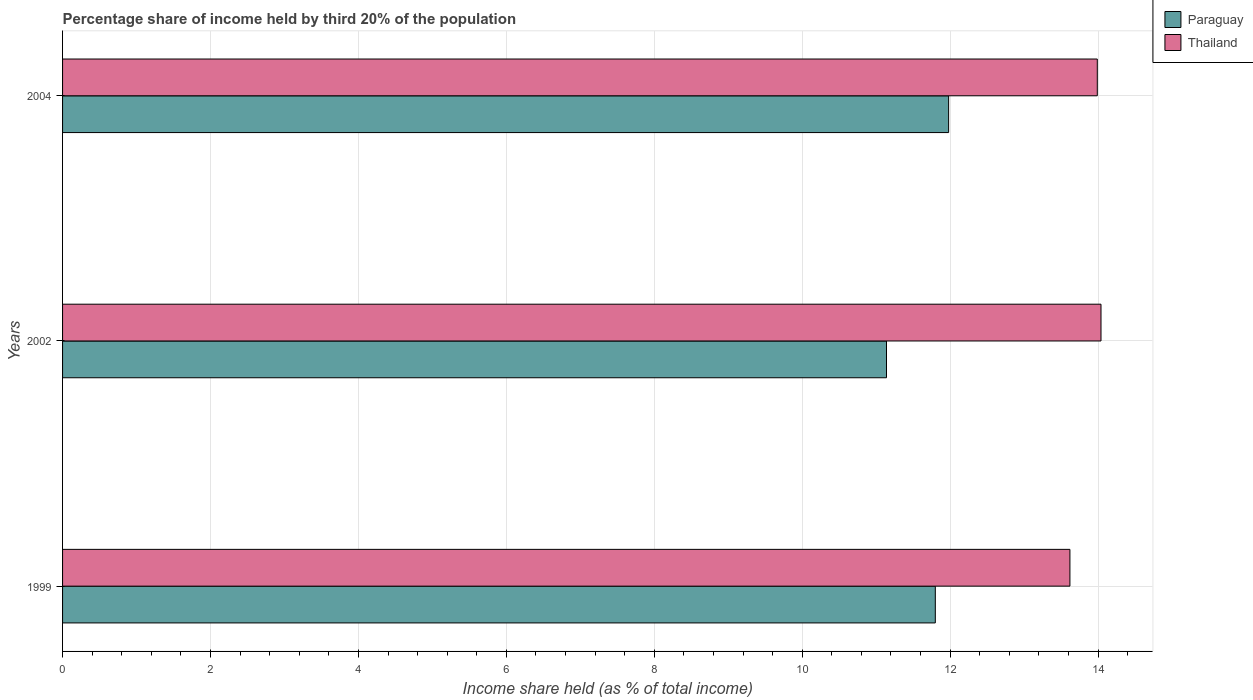How many groups of bars are there?
Keep it short and to the point. 3. Are the number of bars per tick equal to the number of legend labels?
Offer a terse response. Yes. What is the label of the 3rd group of bars from the top?
Keep it short and to the point. 1999. What is the share of income held by third 20% of the population in Thailand in 1999?
Make the answer very short. 13.62. Across all years, what is the maximum share of income held by third 20% of the population in Paraguay?
Your answer should be compact. 11.98. Across all years, what is the minimum share of income held by third 20% of the population in Paraguay?
Make the answer very short. 11.14. In which year was the share of income held by third 20% of the population in Paraguay minimum?
Offer a very short reply. 2002. What is the total share of income held by third 20% of the population in Paraguay in the graph?
Ensure brevity in your answer.  34.92. What is the difference between the share of income held by third 20% of the population in Paraguay in 1999 and that in 2002?
Your answer should be compact. 0.66. What is the difference between the share of income held by third 20% of the population in Paraguay in 2004 and the share of income held by third 20% of the population in Thailand in 1999?
Provide a short and direct response. -1.64. What is the average share of income held by third 20% of the population in Paraguay per year?
Your answer should be compact. 11.64. In the year 2004, what is the difference between the share of income held by third 20% of the population in Thailand and share of income held by third 20% of the population in Paraguay?
Provide a succinct answer. 2.01. What is the ratio of the share of income held by third 20% of the population in Thailand in 1999 to that in 2004?
Give a very brief answer. 0.97. What is the difference between the highest and the second highest share of income held by third 20% of the population in Paraguay?
Make the answer very short. 0.18. What is the difference between the highest and the lowest share of income held by third 20% of the population in Thailand?
Your answer should be compact. 0.42. In how many years, is the share of income held by third 20% of the population in Paraguay greater than the average share of income held by third 20% of the population in Paraguay taken over all years?
Offer a very short reply. 2. Is the sum of the share of income held by third 20% of the population in Thailand in 1999 and 2004 greater than the maximum share of income held by third 20% of the population in Paraguay across all years?
Your answer should be very brief. Yes. What does the 1st bar from the top in 2004 represents?
Your answer should be compact. Thailand. What does the 1st bar from the bottom in 2004 represents?
Provide a short and direct response. Paraguay. Are all the bars in the graph horizontal?
Offer a very short reply. Yes. How many years are there in the graph?
Ensure brevity in your answer.  3. What is the difference between two consecutive major ticks on the X-axis?
Offer a very short reply. 2. Are the values on the major ticks of X-axis written in scientific E-notation?
Offer a very short reply. No. Does the graph contain any zero values?
Your answer should be very brief. No. Where does the legend appear in the graph?
Offer a terse response. Top right. What is the title of the graph?
Keep it short and to the point. Percentage share of income held by third 20% of the population. Does "Bahamas" appear as one of the legend labels in the graph?
Keep it short and to the point. No. What is the label or title of the X-axis?
Offer a terse response. Income share held (as % of total income). What is the Income share held (as % of total income) of Thailand in 1999?
Your answer should be very brief. 13.62. What is the Income share held (as % of total income) in Paraguay in 2002?
Make the answer very short. 11.14. What is the Income share held (as % of total income) of Thailand in 2002?
Offer a terse response. 14.04. What is the Income share held (as % of total income) of Paraguay in 2004?
Your answer should be compact. 11.98. What is the Income share held (as % of total income) in Thailand in 2004?
Your response must be concise. 13.99. Across all years, what is the maximum Income share held (as % of total income) in Paraguay?
Provide a succinct answer. 11.98. Across all years, what is the maximum Income share held (as % of total income) of Thailand?
Offer a very short reply. 14.04. Across all years, what is the minimum Income share held (as % of total income) of Paraguay?
Keep it short and to the point. 11.14. Across all years, what is the minimum Income share held (as % of total income) in Thailand?
Your answer should be compact. 13.62. What is the total Income share held (as % of total income) in Paraguay in the graph?
Ensure brevity in your answer.  34.92. What is the total Income share held (as % of total income) of Thailand in the graph?
Offer a terse response. 41.65. What is the difference between the Income share held (as % of total income) of Paraguay in 1999 and that in 2002?
Your answer should be very brief. 0.66. What is the difference between the Income share held (as % of total income) in Thailand in 1999 and that in 2002?
Offer a terse response. -0.42. What is the difference between the Income share held (as % of total income) in Paraguay in 1999 and that in 2004?
Give a very brief answer. -0.18. What is the difference between the Income share held (as % of total income) of Thailand in 1999 and that in 2004?
Your response must be concise. -0.37. What is the difference between the Income share held (as % of total income) in Paraguay in 2002 and that in 2004?
Ensure brevity in your answer.  -0.84. What is the difference between the Income share held (as % of total income) of Paraguay in 1999 and the Income share held (as % of total income) of Thailand in 2002?
Your answer should be very brief. -2.24. What is the difference between the Income share held (as % of total income) of Paraguay in 1999 and the Income share held (as % of total income) of Thailand in 2004?
Your answer should be very brief. -2.19. What is the difference between the Income share held (as % of total income) of Paraguay in 2002 and the Income share held (as % of total income) of Thailand in 2004?
Offer a terse response. -2.85. What is the average Income share held (as % of total income) in Paraguay per year?
Provide a succinct answer. 11.64. What is the average Income share held (as % of total income) in Thailand per year?
Keep it short and to the point. 13.88. In the year 1999, what is the difference between the Income share held (as % of total income) of Paraguay and Income share held (as % of total income) of Thailand?
Your answer should be compact. -1.82. In the year 2002, what is the difference between the Income share held (as % of total income) of Paraguay and Income share held (as % of total income) of Thailand?
Your answer should be compact. -2.9. In the year 2004, what is the difference between the Income share held (as % of total income) of Paraguay and Income share held (as % of total income) of Thailand?
Offer a terse response. -2.01. What is the ratio of the Income share held (as % of total income) of Paraguay in 1999 to that in 2002?
Provide a succinct answer. 1.06. What is the ratio of the Income share held (as % of total income) in Thailand in 1999 to that in 2002?
Ensure brevity in your answer.  0.97. What is the ratio of the Income share held (as % of total income) of Thailand in 1999 to that in 2004?
Your response must be concise. 0.97. What is the ratio of the Income share held (as % of total income) of Paraguay in 2002 to that in 2004?
Make the answer very short. 0.93. What is the ratio of the Income share held (as % of total income) of Thailand in 2002 to that in 2004?
Ensure brevity in your answer.  1. What is the difference between the highest and the second highest Income share held (as % of total income) in Paraguay?
Give a very brief answer. 0.18. What is the difference between the highest and the lowest Income share held (as % of total income) of Paraguay?
Your response must be concise. 0.84. What is the difference between the highest and the lowest Income share held (as % of total income) in Thailand?
Your response must be concise. 0.42. 